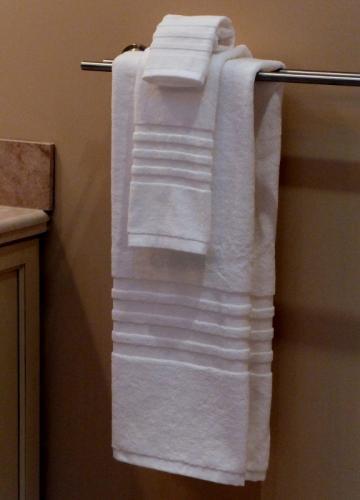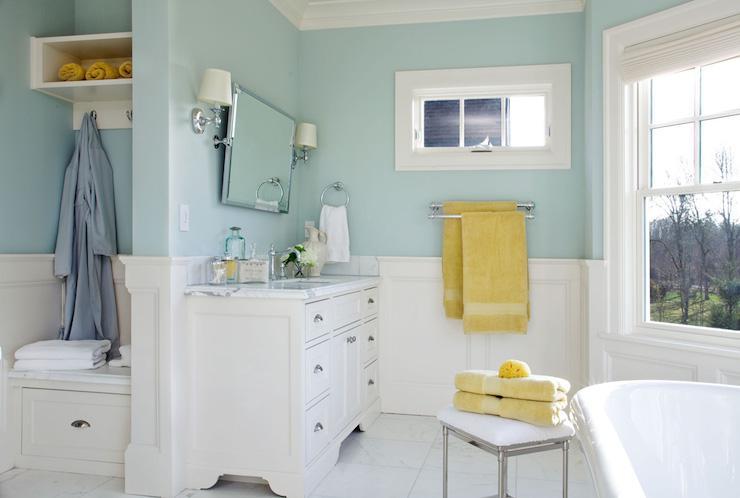The first image is the image on the left, the second image is the image on the right. Given the left and right images, does the statement "One image features side-by-side white towels with smaller towels draped over them on a bar to the right of a shower." hold true? Answer yes or no. No. The first image is the image on the left, the second image is the image on the right. Examine the images to the left and right. Is the description "In at  least one image there are two sets of hand towels next to a striped shower curtain." accurate? Answer yes or no. No. 